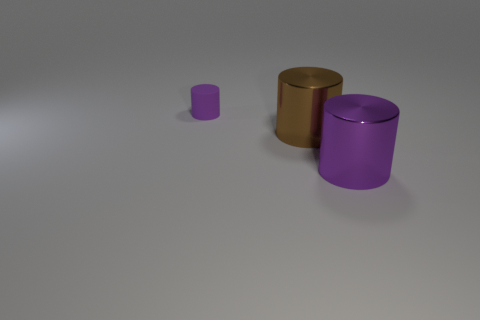There is a large object that is the same color as the tiny cylinder; what is its material?
Ensure brevity in your answer.  Metal. Is there a brown cylinder that is behind the large shiny cylinder that is behind the cylinder that is in front of the large brown cylinder?
Provide a short and direct response. No. How many spheres are brown things or large purple metallic objects?
Ensure brevity in your answer.  0. What material is the purple object in front of the small cylinder?
Your answer should be compact. Metal. There is another thing that is the same color as the rubber object; what size is it?
Provide a short and direct response. Large. There is a cylinder that is in front of the brown metallic cylinder; is its color the same as the cylinder that is behind the brown thing?
Keep it short and to the point. Yes. How many things are small yellow metal spheres or big purple things?
Make the answer very short. 1. What number of other objects are there of the same shape as the large purple thing?
Give a very brief answer. 2. Do the brown cylinder left of the large purple object and the cylinder that is to the left of the big brown metal cylinder have the same material?
Keep it short and to the point. No. What is the shape of the object that is behind the large purple object and to the right of the rubber object?
Make the answer very short. Cylinder. 